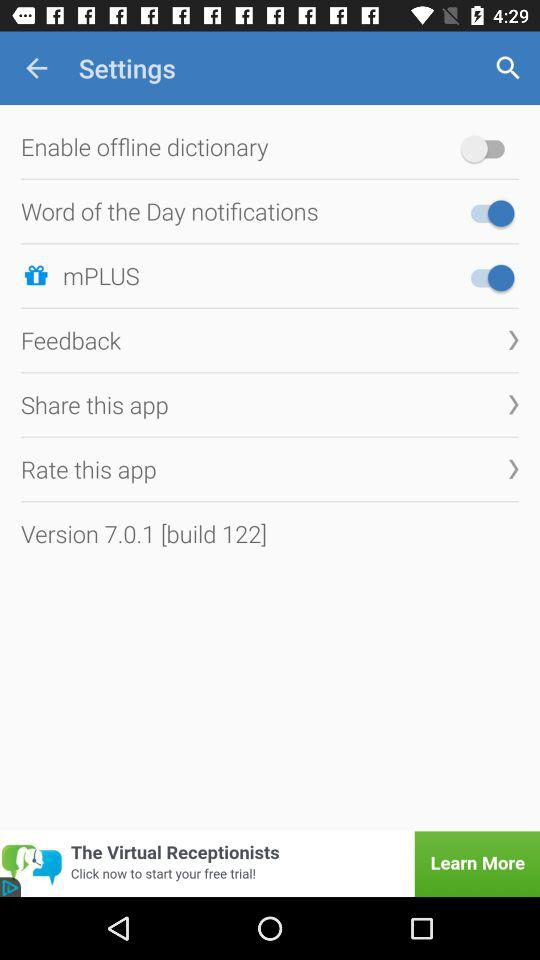What is the version of the application? The version of the application is 7.0.1 [build 122]. 